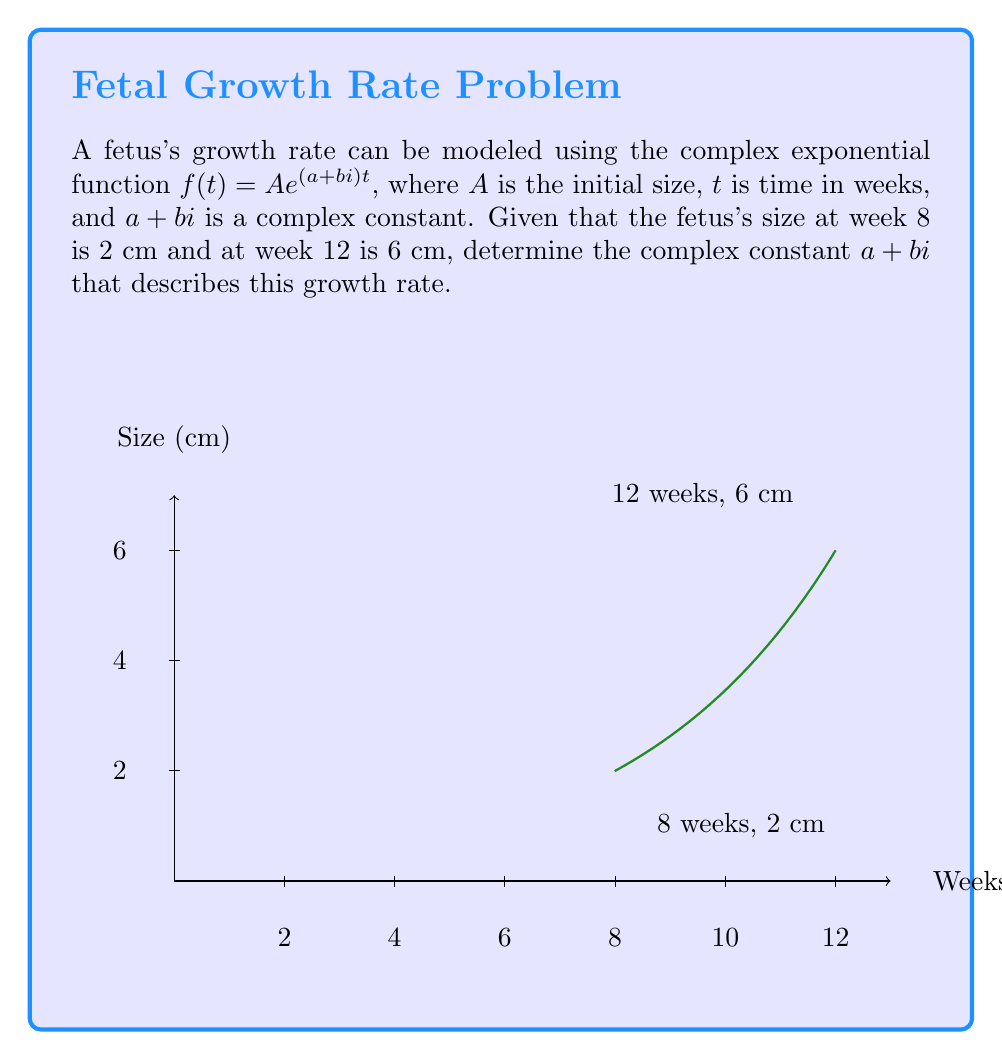Help me with this question. Let's approach this step-by-step:

1) We're given that $f(t) = Ae^{(a+bi)t}$, where $A$ is the initial size at $t=0$.

2) We know two points:
   At $t=8$ weeks, $f(8) = 2$ cm
   At $t=12$ weeks, $f(12) = 6$ cm

3) Let's use these points to set up equations:

   $2 = Ae^{(a+bi)8}$
   $6 = Ae^{(a+bi)12}$

4) Dividing the second equation by the first:

   $\frac{6}{2} = \frac{Ae^{(a+bi)12}}{Ae^{(a+bi)8}}$

5) Simplify:

   $3 = e^{(a+bi)(12-8)} = e^{4(a+bi)}$

6) Taking the natural log of both sides:

   $\ln 3 = 4(a+bi)$

7) The imaginary part must be zero for this equation to hold, so $b=0$.

8) Solving for $a$:

   $a = \frac{\ln 3}{4} \approx 0.27466$

9) Therefore, the complex constant $a+bi$ is approximately $0.27466 + 0i$.

10) To verify, we can calculate $A$:

    $2 = Ae^{0.27466 * 8}$
    $A = 2e^{-0.27466 * 8} \approx 0.6065$

    And check: $0.6065e^{0.27466 * 12} \approx 6$ cm, which matches our given data.
Answer: $a+bi \approx 0.27466 + 0i$ 